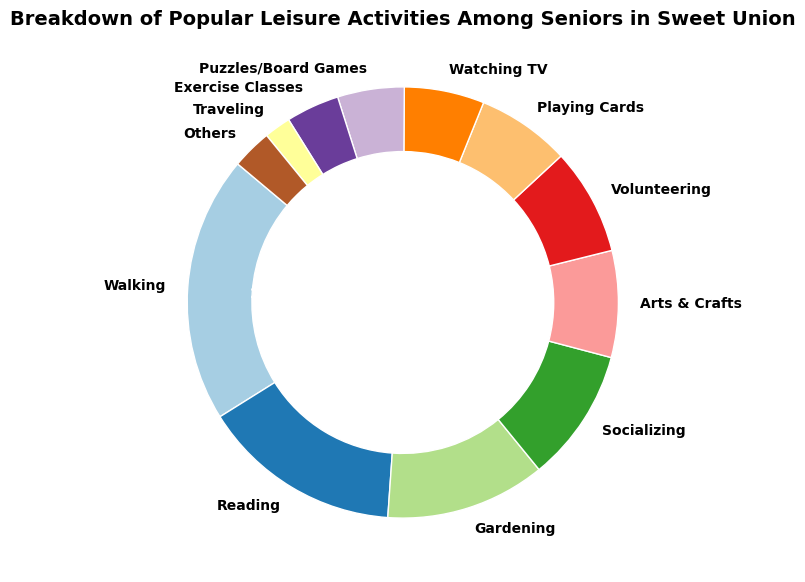What is the percentage of seniors who enjoy walking? The percentage of seniors who enjoy walking is shown directly on the pie chart as 20%.
Answer: 20% Which activity has a higher percentage of participants: Playing Cards or Gardening? The chart shows that Gardening has a percentage of 12% and Playing Cards 7%. Comparing these, Gardening has a higher percentage.
Answer: Gardening How much higher in percentage is Walking compared to Reading? Walking is 20% and Reading is 15%. The difference between these two is 20% - 15% = 5%.
Answer: 5% What are the top three most popular activities among seniors? Observing the pie chart, the three activities with the largest sections are Walking (20%), Reading (15%), and Gardening (12%).
Answer: Walking, Reading, Gardening What is the combined percentage of seniors participating in Socializing, Arts & Crafts, and Volunteering? The percentages are 10% for Socializing, 8% for Arts & Crafts, and 8% for Volunteering. Adding these, 10% + 8% + 8% = 26%.
Answer: 26% Which activity has the smallest representation on the chart? The pie chart indicates that Traveling has the smallest percentage at 2%.
Answer: Traveling If you combine the percentages for Watching TV and Puzzles/Board Games, how does the total compare to Socializing? Watching TV is 6% and Puzzles/Board Games is 5%. Their combined sum is 6% + 5% = 11%, which is higher than Socializing at 10%.
Answer: Higher What is the median value of the percentages shown in the chart? Listed in order: 2%, 3%, 4%, 5%, 6%, 7%, 8%, 8%, 10%, 12%, 15%, 20%. The median of these 12 values is the average of the 6th and 7th values, (7% + 8%)/2 = 7.5%.
Answer: 7.5% Is the percentage of seniors participating in Exercise Classes greater than those in Watching TV? The percentage for Exercise Classes is 4% and for Watching TV is 6%. Exercise Classes have a smaller percentage than Watching TV.
Answer: No What fraction of seniors are involved in activities that have a percentage less than 10%? The activities with less than 10% are Arts & Crafts (8%), Volunteering (8%), Playing Cards (7%), Watching TV (6%), Puzzles/Board Games (5%), Exercise Classes (4%), Traveling (2%), and Others (3%). Their combined percentage is 8% + 8% + 7% + 6% + 5% + 4% + 2% + 3% = 43%.
Answer: 43% 